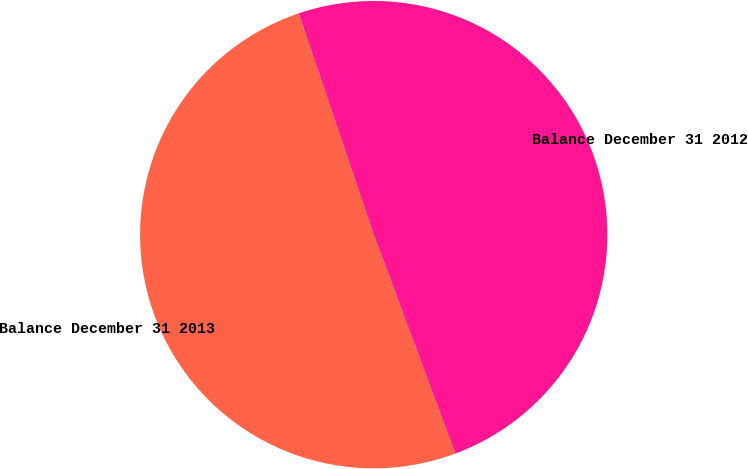Convert chart to OTSL. <chart><loc_0><loc_0><loc_500><loc_500><pie_chart><fcel>Balance December 31 2012<fcel>Balance December 31 2013<nl><fcel>49.53%<fcel>50.47%<nl></chart> 